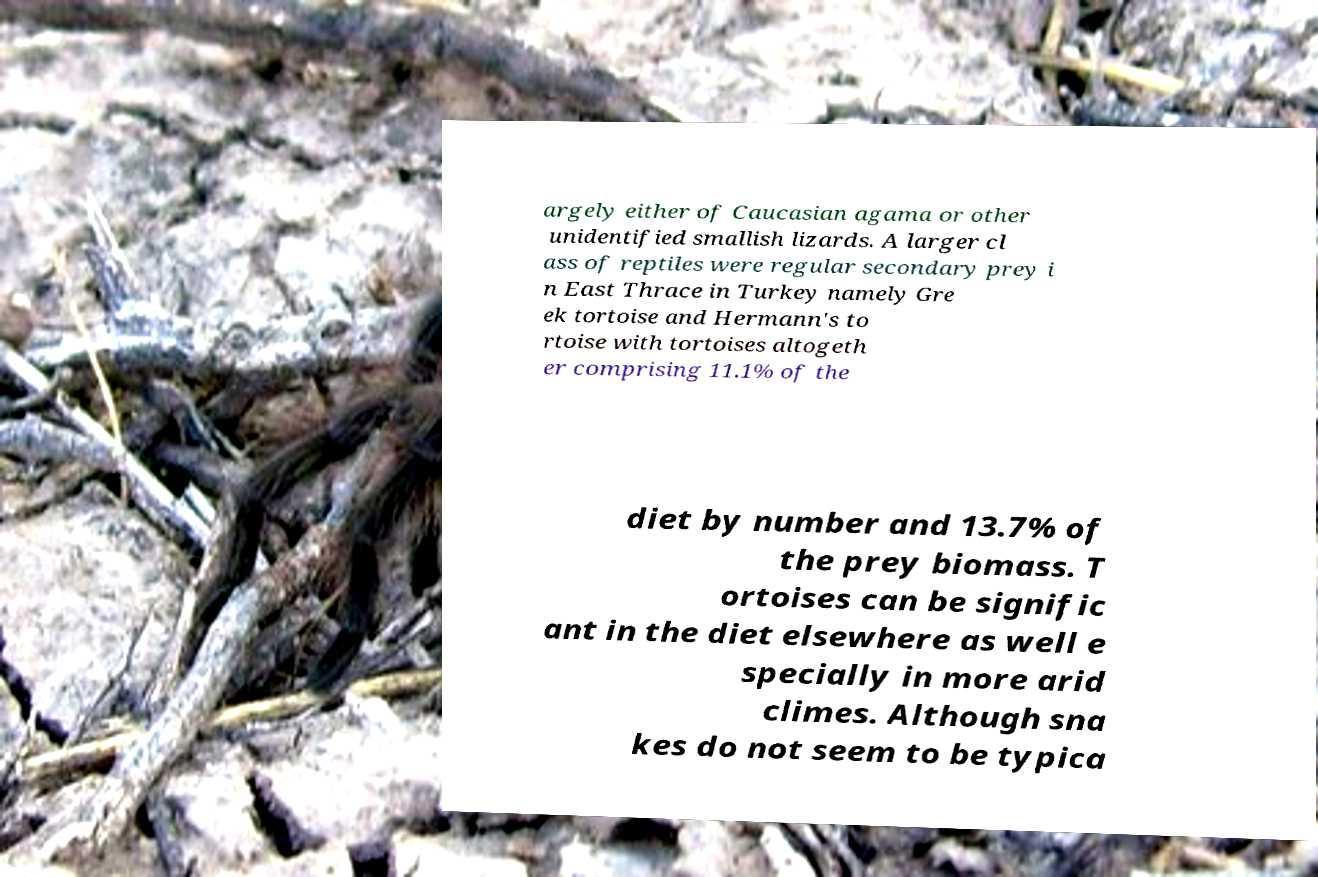Can you accurately transcribe the text from the provided image for me? argely either of Caucasian agama or other unidentified smallish lizards. A larger cl ass of reptiles were regular secondary prey i n East Thrace in Turkey namely Gre ek tortoise and Hermann's to rtoise with tortoises altogeth er comprising 11.1% of the diet by number and 13.7% of the prey biomass. T ortoises can be signific ant in the diet elsewhere as well e specially in more arid climes. Although sna kes do not seem to be typica 